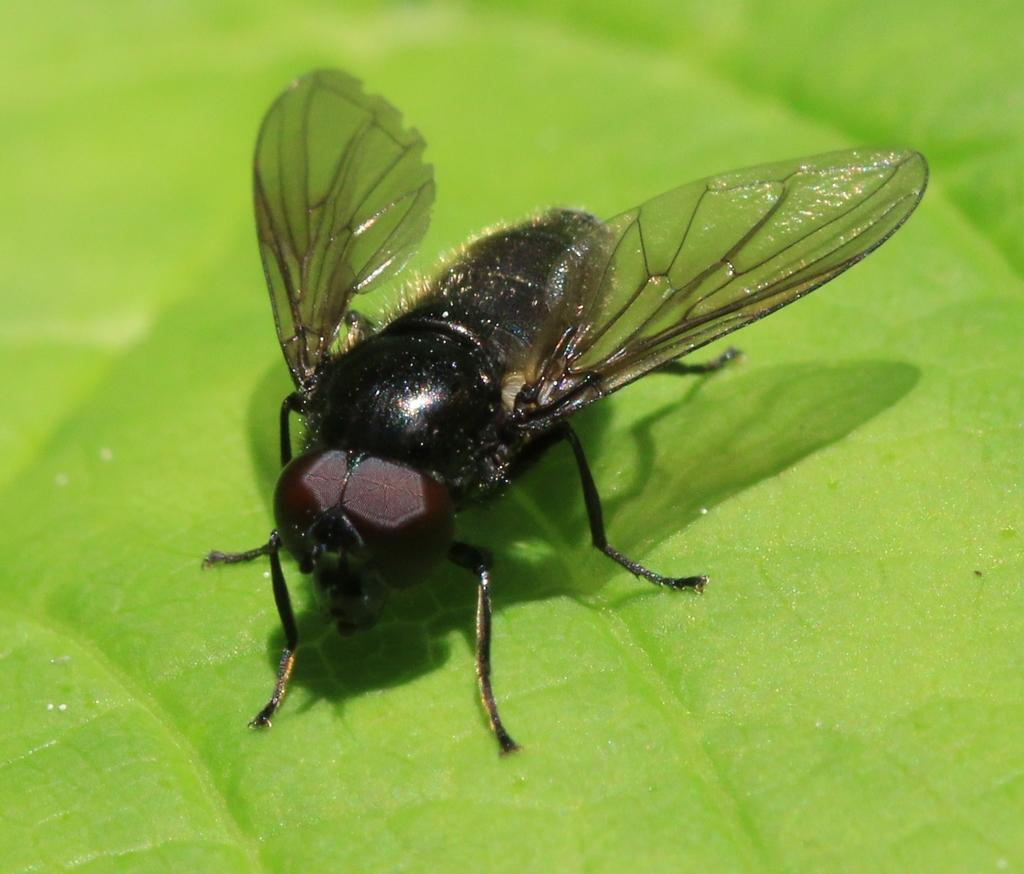What type of creature is present in the image? There is an insect in the image. What is the insect sitting on? The insect is on a green surface. What does the green surface resemble? The green surface resembles a leaf. What type of pancake is being served at the party in the image? There is no party or pancake present in the image; it features an insect on a leaf. 